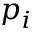Convert formula to latex. <formula><loc_0><loc_0><loc_500><loc_500>p _ { i }</formula> 